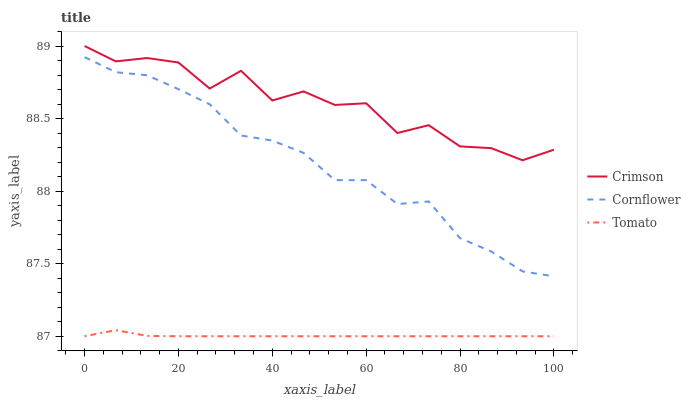Does Tomato have the minimum area under the curve?
Answer yes or no. Yes. Does Crimson have the maximum area under the curve?
Answer yes or no. Yes. Does Cornflower have the minimum area under the curve?
Answer yes or no. No. Does Cornflower have the maximum area under the curve?
Answer yes or no. No. Is Tomato the smoothest?
Answer yes or no. Yes. Is Crimson the roughest?
Answer yes or no. Yes. Is Cornflower the smoothest?
Answer yes or no. No. Is Cornflower the roughest?
Answer yes or no. No. Does Tomato have the lowest value?
Answer yes or no. Yes. Does Cornflower have the lowest value?
Answer yes or no. No. Does Crimson have the highest value?
Answer yes or no. Yes. Does Cornflower have the highest value?
Answer yes or no. No. Is Tomato less than Crimson?
Answer yes or no. Yes. Is Crimson greater than Tomato?
Answer yes or no. Yes. Does Tomato intersect Crimson?
Answer yes or no. No. 